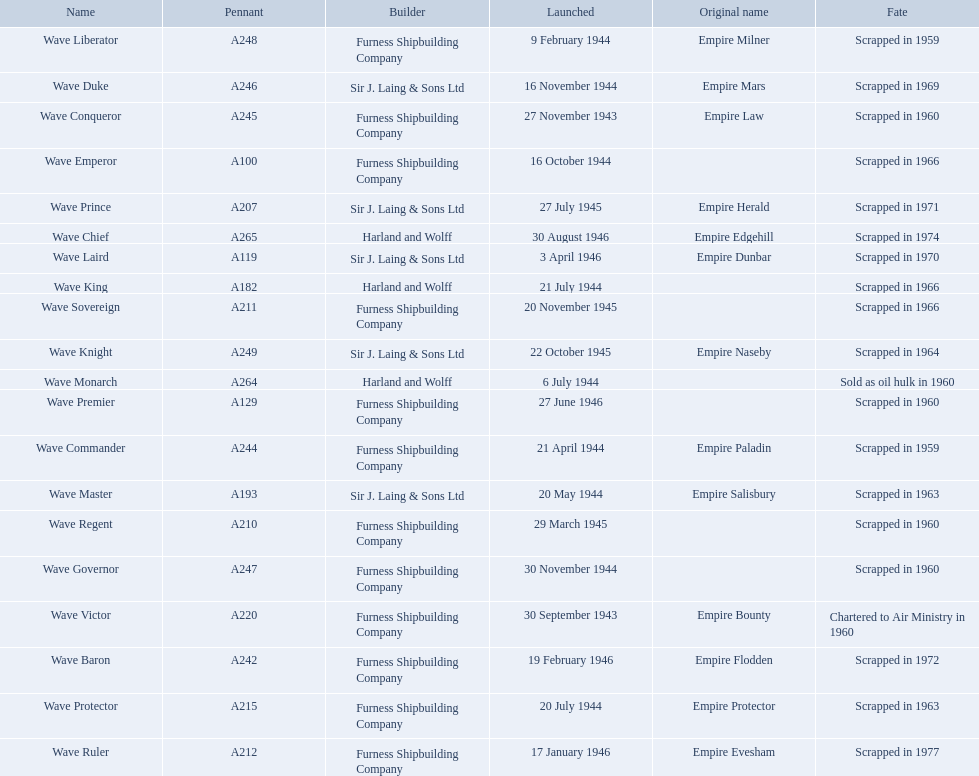What builders launched ships in november of any year? Furness Shipbuilding Company, Sir J. Laing & Sons Ltd, Furness Shipbuilding Company, Furness Shipbuilding Company. What ship builders ships had their original name's changed prior to scrapping? Furness Shipbuilding Company, Sir J. Laing & Sons Ltd. What was the name of the ship that was built in november and had its name changed prior to scrapping only 12 years after its launch? Wave Conqueror. What year was the wave victor launched? 30 September 1943. What other ship was launched in 1943? Wave Conqueror. 